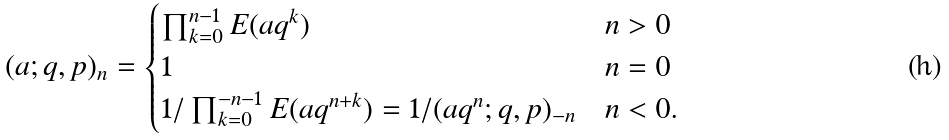Convert formula to latex. <formula><loc_0><loc_0><loc_500><loc_500>( a ; q , p ) _ { n } = \begin{cases} \prod _ { k = 0 } ^ { n - 1 } E ( a q ^ { k } ) & \text {$n>0$} \\ 1 & \text {$n=0$} \\ 1 / \prod _ { k = 0 } ^ { - n - 1 } E ( a q ^ { n + k } ) = 1 / ( a q ^ { n } ; q , p ) _ { - n } & \text {$n<0$.} \end{cases}</formula> 